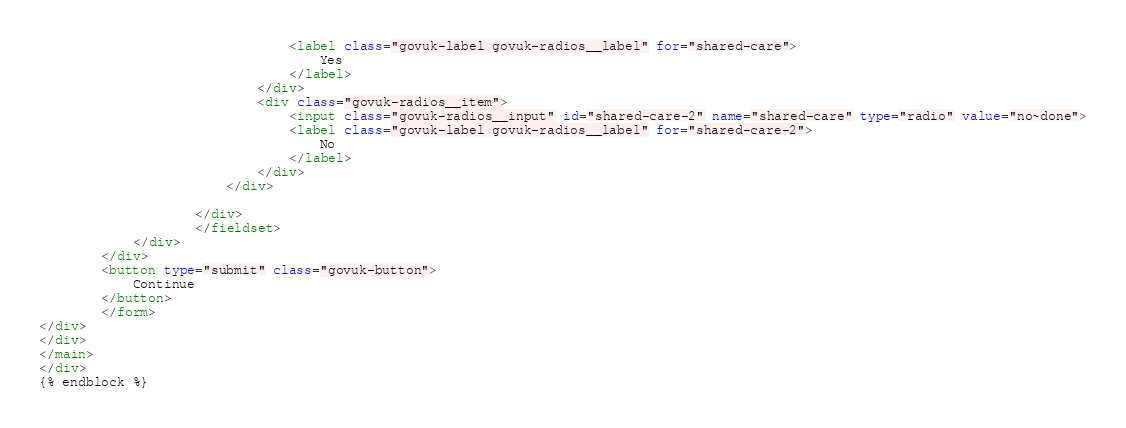<code> <loc_0><loc_0><loc_500><loc_500><_HTML_>                                <label class="govuk-label govuk-radios__label" for="shared-care">
                                    Yes
                                </label>
                            </div>
                            <div class="govuk-radios__item">
                                <input class="govuk-radios__input" id="shared-care-2" name="shared-care" type="radio" value="no~done">
                                <label class="govuk-label govuk-radios__label" for="shared-care-2">
                                    No
                                </label>
                            </div>
                        </div>

                    </div>
                    </fieldset>
            </div>
        </div>
        <button type="submit" class="govuk-button">
            Continue
        </button>
        </form>
</div>
</div>
</main>
</div>
{% endblock %}</code> 